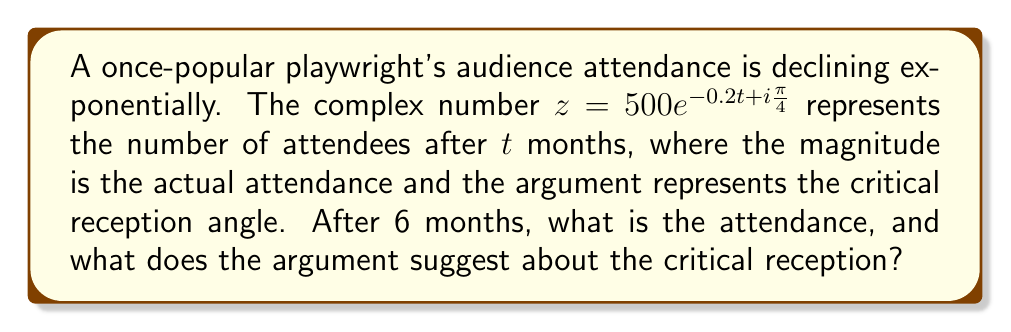Help me with this question. Let's approach this step-by-step:

1) We are given the complex number in polar form: $z = 500e^{-0.2t + i\frac{\pi}{4}}$

2) We need to evaluate this for $t = 6$ months:
   $z = 500e^{-0.2(6) + i\frac{\pi}{4}}$
   $z = 500e^{-1.2 + i\frac{\pi}{4}}$

3) To find the attendance, we need to calculate the magnitude of this complex number:
   $|z| = 500e^{-1.2} \approx 150.97$

4) The attendance after 6 months is approximately 151 people (rounded to the nearest whole number).

5) The argument of the complex number remains constant at $\frac{\pi}{4}$ radians or 45°.

6) In the context of critical reception, an argument of 45° could be interpreted as a mixed or neutral reception. It's neither strongly positive (which might be closer to 90°) nor strongly negative (which might be closer to 0° or 360°).
Answer: 151 attendees; neutral critical reception 